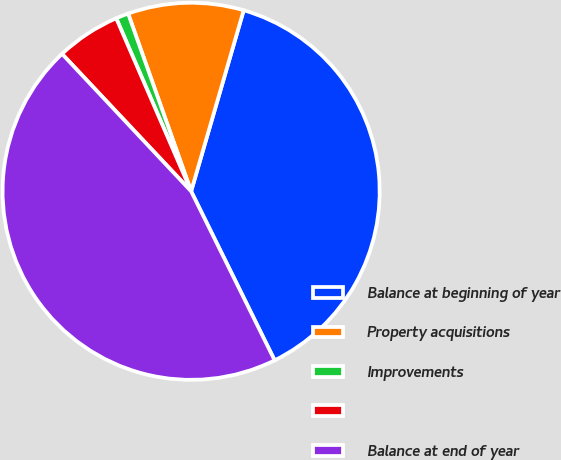Convert chart to OTSL. <chart><loc_0><loc_0><loc_500><loc_500><pie_chart><fcel>Balance at beginning of year<fcel>Property acquisitions<fcel>Improvements<fcel>Unnamed: 3<fcel>Balance at end of year<nl><fcel>38.2%<fcel>9.92%<fcel>1.08%<fcel>5.5%<fcel>45.3%<nl></chart> 